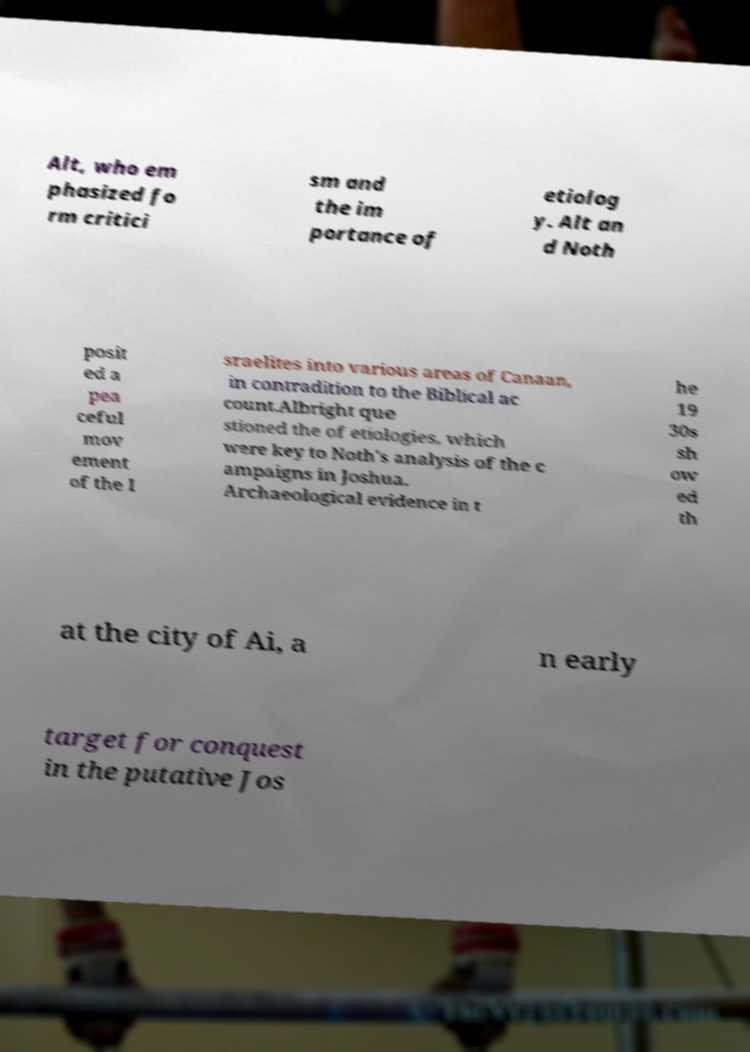Please read and relay the text visible in this image. What does it say? Alt, who em phasized fo rm critici sm and the im portance of etiolog y. Alt an d Noth posit ed a pea ceful mov ement of the I sraelites into various areas of Canaan, in contradition to the Biblical ac count.Albright que stioned the of etiologies, which were key to Noth's analysis of the c ampaigns in Joshua. Archaeological evidence in t he 19 30s sh ow ed th at the city of Ai, a n early target for conquest in the putative Jos 